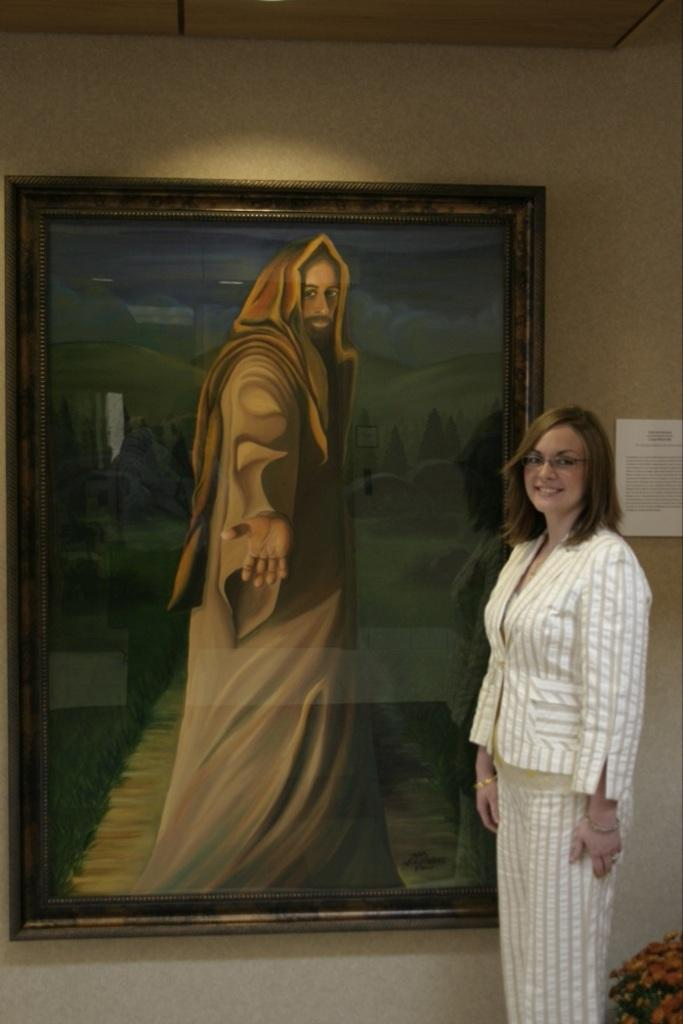Who is the main subject in the image? There is a woman in the image. What is the woman standing in front of? The woman is standing in front of a portrait. How is the portrait displayed in the image? The portrait is attached to the wall. What additional information is provided near the portrait? There is a notice beside the portrait. What type of liquid is being heated in the image? There is no liquid or heating element present in the image. 